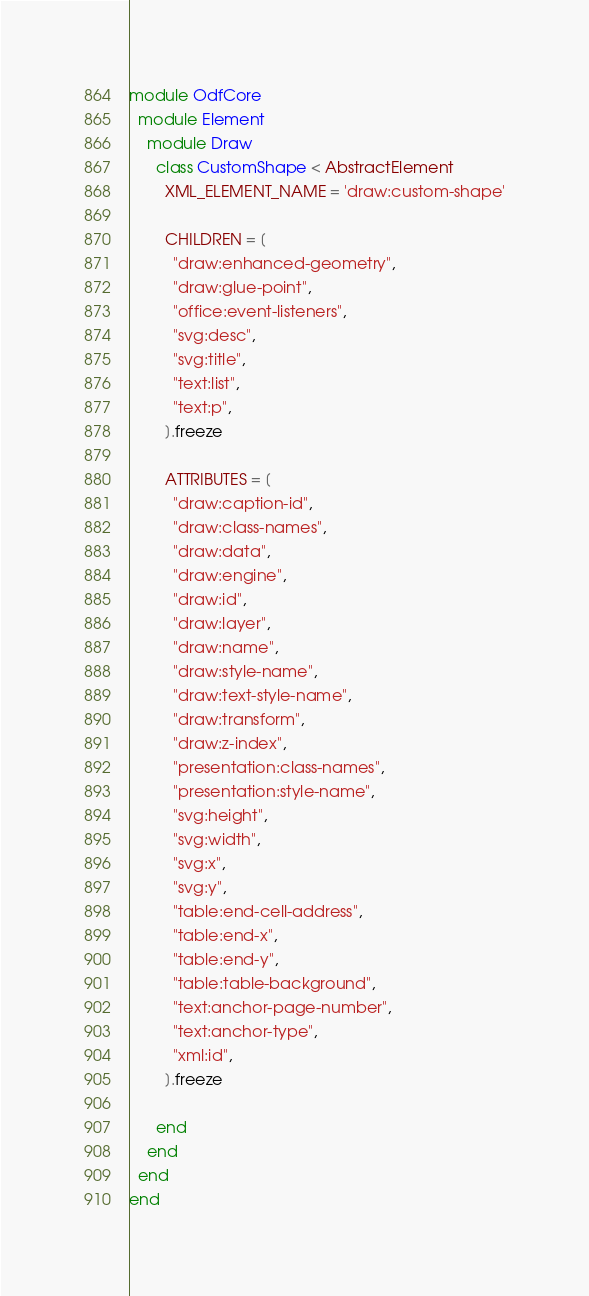Convert code to text. <code><loc_0><loc_0><loc_500><loc_500><_Ruby_>module OdfCore
  module Element
    module Draw
      class CustomShape < AbstractElement
        XML_ELEMENT_NAME = 'draw:custom-shape'

        CHILDREN = [
          "draw:enhanced-geometry",
          "draw:glue-point",
          "office:event-listeners",
          "svg:desc",
          "svg:title",
          "text:list",
          "text:p",
        ].freeze

        ATTRIBUTES = [
          "draw:caption-id",
          "draw:class-names",
          "draw:data",
          "draw:engine",
          "draw:id",
          "draw:layer",
          "draw:name",
          "draw:style-name",
          "draw:text-style-name",
          "draw:transform",
          "draw:z-index",
          "presentation:class-names",
          "presentation:style-name",
          "svg:height",
          "svg:width",
          "svg:x",
          "svg:y",
          "table:end-cell-address",
          "table:end-x",
          "table:end-y",
          "table:table-background",
          "text:anchor-page-number",
          "text:anchor-type",
          "xml:id",
        ].freeze

      end
    end
  end
end
</code> 